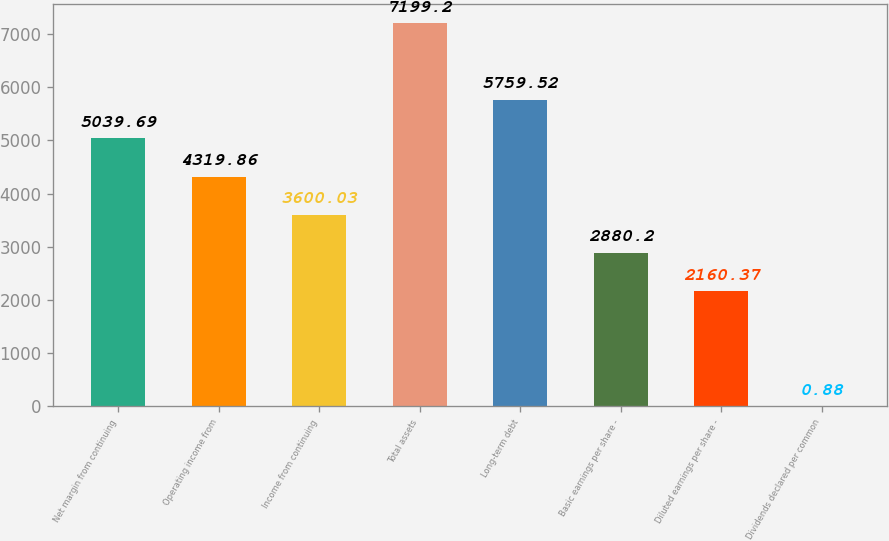Convert chart. <chart><loc_0><loc_0><loc_500><loc_500><bar_chart><fcel>Net margin from continuing<fcel>Operating income from<fcel>Income from continuing<fcel>Total assets<fcel>Long-term debt<fcel>Basic earnings per share -<fcel>Diluted earnings per share -<fcel>Dividends declared per common<nl><fcel>5039.69<fcel>4319.86<fcel>3600.03<fcel>7199.2<fcel>5759.52<fcel>2880.2<fcel>2160.37<fcel>0.88<nl></chart> 